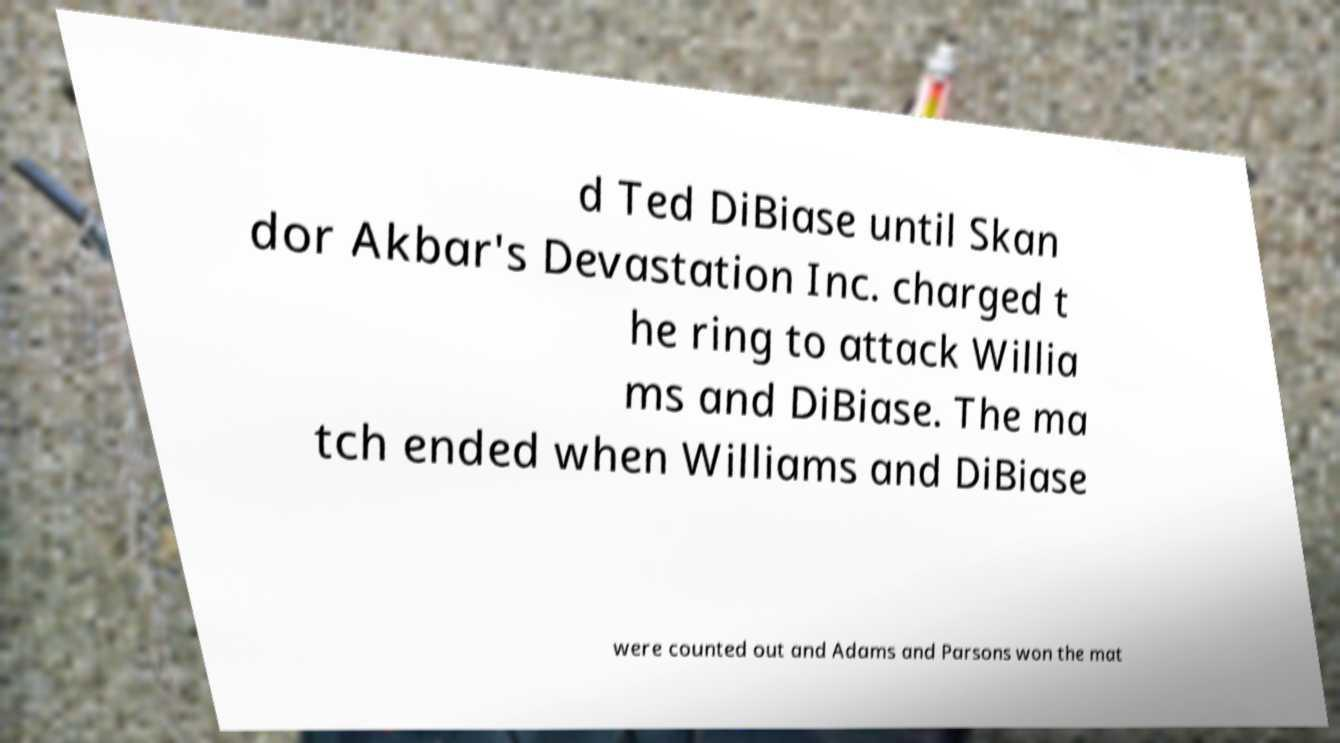Please identify and transcribe the text found in this image. d Ted DiBiase until Skan dor Akbar's Devastation Inc. charged t he ring to attack Willia ms and DiBiase. The ma tch ended when Williams and DiBiase were counted out and Adams and Parsons won the mat 